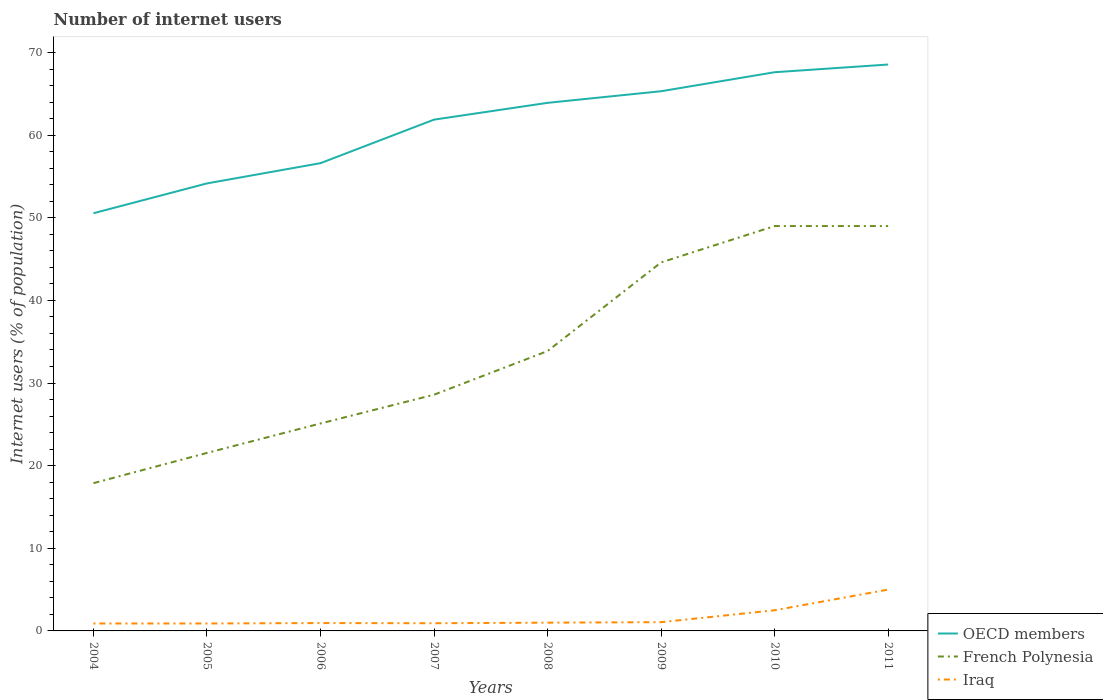Is the number of lines equal to the number of legend labels?
Provide a short and direct response. Yes. Across all years, what is the maximum number of internet users in French Polynesia?
Your answer should be very brief. 17.88. What is the total number of internet users in OECD members in the graph?
Offer a very short reply. -7.72. What is the difference between the highest and the second highest number of internet users in French Polynesia?
Keep it short and to the point. 31.12. What is the difference between the highest and the lowest number of internet users in French Polynesia?
Offer a very short reply. 4. How many years are there in the graph?
Offer a very short reply. 8. What is the difference between two consecutive major ticks on the Y-axis?
Offer a very short reply. 10. Does the graph contain any zero values?
Your answer should be very brief. No. Where does the legend appear in the graph?
Provide a short and direct response. Bottom right. How many legend labels are there?
Your answer should be compact. 3. What is the title of the graph?
Ensure brevity in your answer.  Number of internet users. Does "Suriname" appear as one of the legend labels in the graph?
Provide a short and direct response. No. What is the label or title of the X-axis?
Provide a short and direct response. Years. What is the label or title of the Y-axis?
Give a very brief answer. Internet users (% of population). What is the Internet users (% of population) of OECD members in 2004?
Your answer should be very brief. 50.55. What is the Internet users (% of population) of French Polynesia in 2004?
Provide a succinct answer. 17.88. What is the Internet users (% of population) in OECD members in 2005?
Your answer should be very brief. 54.16. What is the Internet users (% of population) in French Polynesia in 2005?
Provide a succinct answer. 21.54. What is the Internet users (% of population) in Iraq in 2005?
Your answer should be very brief. 0.9. What is the Internet users (% of population) in OECD members in 2006?
Give a very brief answer. 56.61. What is the Internet users (% of population) in French Polynesia in 2006?
Keep it short and to the point. 25.11. What is the Internet users (% of population) of Iraq in 2006?
Keep it short and to the point. 0.95. What is the Internet users (% of population) in OECD members in 2007?
Provide a short and direct response. 61.88. What is the Internet users (% of population) in French Polynesia in 2007?
Keep it short and to the point. 28.59. What is the Internet users (% of population) of Iraq in 2007?
Provide a short and direct response. 0.93. What is the Internet users (% of population) of OECD members in 2008?
Your answer should be very brief. 63.91. What is the Internet users (% of population) in French Polynesia in 2008?
Your answer should be very brief. 33.87. What is the Internet users (% of population) of Iraq in 2008?
Your answer should be very brief. 1. What is the Internet users (% of population) of OECD members in 2009?
Give a very brief answer. 65.32. What is the Internet users (% of population) in French Polynesia in 2009?
Your answer should be compact. 44.6. What is the Internet users (% of population) of Iraq in 2009?
Offer a terse response. 1.06. What is the Internet users (% of population) of OECD members in 2010?
Your response must be concise. 67.62. What is the Internet users (% of population) in French Polynesia in 2010?
Your answer should be compact. 49. What is the Internet users (% of population) in OECD members in 2011?
Give a very brief answer. 68.55. What is the Internet users (% of population) of French Polynesia in 2011?
Offer a very short reply. 49. What is the Internet users (% of population) in Iraq in 2011?
Keep it short and to the point. 5. Across all years, what is the maximum Internet users (% of population) in OECD members?
Give a very brief answer. 68.55. Across all years, what is the maximum Internet users (% of population) of French Polynesia?
Give a very brief answer. 49. Across all years, what is the maximum Internet users (% of population) of Iraq?
Provide a short and direct response. 5. Across all years, what is the minimum Internet users (% of population) in OECD members?
Your answer should be very brief. 50.55. Across all years, what is the minimum Internet users (% of population) in French Polynesia?
Offer a terse response. 17.88. Across all years, what is the minimum Internet users (% of population) of Iraq?
Offer a very short reply. 0.9. What is the total Internet users (% of population) of OECD members in the graph?
Make the answer very short. 488.61. What is the total Internet users (% of population) of French Polynesia in the graph?
Keep it short and to the point. 269.59. What is the total Internet users (% of population) in Iraq in the graph?
Your answer should be very brief. 13.24. What is the difference between the Internet users (% of population) of OECD members in 2004 and that in 2005?
Ensure brevity in your answer.  -3.61. What is the difference between the Internet users (% of population) of French Polynesia in 2004 and that in 2005?
Your answer should be very brief. -3.66. What is the difference between the Internet users (% of population) in OECD members in 2004 and that in 2006?
Your answer should be very brief. -6.06. What is the difference between the Internet users (% of population) in French Polynesia in 2004 and that in 2006?
Your answer should be very brief. -7.22. What is the difference between the Internet users (% of population) of Iraq in 2004 and that in 2006?
Your answer should be very brief. -0.05. What is the difference between the Internet users (% of population) in OECD members in 2004 and that in 2007?
Your answer should be compact. -11.33. What is the difference between the Internet users (% of population) in French Polynesia in 2004 and that in 2007?
Your response must be concise. -10.71. What is the difference between the Internet users (% of population) in Iraq in 2004 and that in 2007?
Offer a very short reply. -0.03. What is the difference between the Internet users (% of population) of OECD members in 2004 and that in 2008?
Your answer should be compact. -13.36. What is the difference between the Internet users (% of population) in French Polynesia in 2004 and that in 2008?
Offer a terse response. -15.99. What is the difference between the Internet users (% of population) of OECD members in 2004 and that in 2009?
Provide a succinct answer. -14.77. What is the difference between the Internet users (% of population) in French Polynesia in 2004 and that in 2009?
Keep it short and to the point. -26.72. What is the difference between the Internet users (% of population) of Iraq in 2004 and that in 2009?
Your answer should be compact. -0.16. What is the difference between the Internet users (% of population) of OECD members in 2004 and that in 2010?
Keep it short and to the point. -17.07. What is the difference between the Internet users (% of population) in French Polynesia in 2004 and that in 2010?
Give a very brief answer. -31.12. What is the difference between the Internet users (% of population) in OECD members in 2004 and that in 2011?
Ensure brevity in your answer.  -18. What is the difference between the Internet users (% of population) of French Polynesia in 2004 and that in 2011?
Keep it short and to the point. -31.12. What is the difference between the Internet users (% of population) in Iraq in 2004 and that in 2011?
Offer a very short reply. -4.1. What is the difference between the Internet users (% of population) in OECD members in 2005 and that in 2006?
Your answer should be compact. -2.45. What is the difference between the Internet users (% of population) in French Polynesia in 2005 and that in 2006?
Your answer should be very brief. -3.57. What is the difference between the Internet users (% of population) of Iraq in 2005 and that in 2006?
Give a very brief answer. -0.05. What is the difference between the Internet users (% of population) in OECD members in 2005 and that in 2007?
Provide a succinct answer. -7.72. What is the difference between the Internet users (% of population) of French Polynesia in 2005 and that in 2007?
Keep it short and to the point. -7.05. What is the difference between the Internet users (% of population) of Iraq in 2005 and that in 2007?
Provide a short and direct response. -0.03. What is the difference between the Internet users (% of population) of OECD members in 2005 and that in 2008?
Make the answer very short. -9.75. What is the difference between the Internet users (% of population) of French Polynesia in 2005 and that in 2008?
Provide a succinct answer. -12.33. What is the difference between the Internet users (% of population) of Iraq in 2005 and that in 2008?
Offer a very short reply. -0.1. What is the difference between the Internet users (% of population) of OECD members in 2005 and that in 2009?
Offer a very short reply. -11.16. What is the difference between the Internet users (% of population) in French Polynesia in 2005 and that in 2009?
Provide a succinct answer. -23.06. What is the difference between the Internet users (% of population) in Iraq in 2005 and that in 2009?
Ensure brevity in your answer.  -0.16. What is the difference between the Internet users (% of population) of OECD members in 2005 and that in 2010?
Your response must be concise. -13.46. What is the difference between the Internet users (% of population) of French Polynesia in 2005 and that in 2010?
Provide a succinct answer. -27.46. What is the difference between the Internet users (% of population) in OECD members in 2005 and that in 2011?
Give a very brief answer. -14.39. What is the difference between the Internet users (% of population) of French Polynesia in 2005 and that in 2011?
Provide a succinct answer. -27.46. What is the difference between the Internet users (% of population) of Iraq in 2005 and that in 2011?
Ensure brevity in your answer.  -4.1. What is the difference between the Internet users (% of population) of OECD members in 2006 and that in 2007?
Ensure brevity in your answer.  -5.27. What is the difference between the Internet users (% of population) of French Polynesia in 2006 and that in 2007?
Provide a short and direct response. -3.48. What is the difference between the Internet users (% of population) of Iraq in 2006 and that in 2007?
Your response must be concise. 0.02. What is the difference between the Internet users (% of population) of OECD members in 2006 and that in 2008?
Your response must be concise. -7.3. What is the difference between the Internet users (% of population) of French Polynesia in 2006 and that in 2008?
Provide a succinct answer. -8.76. What is the difference between the Internet users (% of population) in Iraq in 2006 and that in 2008?
Give a very brief answer. -0.05. What is the difference between the Internet users (% of population) of OECD members in 2006 and that in 2009?
Your answer should be compact. -8.71. What is the difference between the Internet users (% of population) of French Polynesia in 2006 and that in 2009?
Offer a very short reply. -19.49. What is the difference between the Internet users (% of population) in Iraq in 2006 and that in 2009?
Offer a terse response. -0.11. What is the difference between the Internet users (% of population) of OECD members in 2006 and that in 2010?
Provide a succinct answer. -11.01. What is the difference between the Internet users (% of population) of French Polynesia in 2006 and that in 2010?
Provide a succinct answer. -23.89. What is the difference between the Internet users (% of population) in Iraq in 2006 and that in 2010?
Your answer should be very brief. -1.55. What is the difference between the Internet users (% of population) in OECD members in 2006 and that in 2011?
Offer a terse response. -11.94. What is the difference between the Internet users (% of population) in French Polynesia in 2006 and that in 2011?
Give a very brief answer. -23.89. What is the difference between the Internet users (% of population) of Iraq in 2006 and that in 2011?
Ensure brevity in your answer.  -4.05. What is the difference between the Internet users (% of population) in OECD members in 2007 and that in 2008?
Your answer should be compact. -2.03. What is the difference between the Internet users (% of population) of French Polynesia in 2007 and that in 2008?
Ensure brevity in your answer.  -5.28. What is the difference between the Internet users (% of population) in Iraq in 2007 and that in 2008?
Keep it short and to the point. -0.07. What is the difference between the Internet users (% of population) in OECD members in 2007 and that in 2009?
Offer a terse response. -3.44. What is the difference between the Internet users (% of population) in French Polynesia in 2007 and that in 2009?
Make the answer very short. -16.01. What is the difference between the Internet users (% of population) in Iraq in 2007 and that in 2009?
Provide a short and direct response. -0.13. What is the difference between the Internet users (% of population) in OECD members in 2007 and that in 2010?
Give a very brief answer. -5.74. What is the difference between the Internet users (% of population) of French Polynesia in 2007 and that in 2010?
Keep it short and to the point. -20.41. What is the difference between the Internet users (% of population) in Iraq in 2007 and that in 2010?
Your answer should be very brief. -1.57. What is the difference between the Internet users (% of population) of OECD members in 2007 and that in 2011?
Offer a very short reply. -6.67. What is the difference between the Internet users (% of population) in French Polynesia in 2007 and that in 2011?
Ensure brevity in your answer.  -20.41. What is the difference between the Internet users (% of population) of Iraq in 2007 and that in 2011?
Give a very brief answer. -4.07. What is the difference between the Internet users (% of population) of OECD members in 2008 and that in 2009?
Your response must be concise. -1.41. What is the difference between the Internet users (% of population) in French Polynesia in 2008 and that in 2009?
Provide a succinct answer. -10.73. What is the difference between the Internet users (% of population) in Iraq in 2008 and that in 2009?
Your response must be concise. -0.06. What is the difference between the Internet users (% of population) in OECD members in 2008 and that in 2010?
Ensure brevity in your answer.  -3.71. What is the difference between the Internet users (% of population) in French Polynesia in 2008 and that in 2010?
Your answer should be compact. -15.13. What is the difference between the Internet users (% of population) of OECD members in 2008 and that in 2011?
Provide a succinct answer. -4.64. What is the difference between the Internet users (% of population) in French Polynesia in 2008 and that in 2011?
Ensure brevity in your answer.  -15.13. What is the difference between the Internet users (% of population) of Iraq in 2008 and that in 2011?
Make the answer very short. -4. What is the difference between the Internet users (% of population) in OECD members in 2009 and that in 2010?
Give a very brief answer. -2.3. What is the difference between the Internet users (% of population) of Iraq in 2009 and that in 2010?
Keep it short and to the point. -1.44. What is the difference between the Internet users (% of population) in OECD members in 2009 and that in 2011?
Give a very brief answer. -3.23. What is the difference between the Internet users (% of population) in Iraq in 2009 and that in 2011?
Offer a terse response. -3.94. What is the difference between the Internet users (% of population) of OECD members in 2010 and that in 2011?
Keep it short and to the point. -0.93. What is the difference between the Internet users (% of population) in French Polynesia in 2010 and that in 2011?
Ensure brevity in your answer.  0. What is the difference between the Internet users (% of population) in Iraq in 2010 and that in 2011?
Your answer should be compact. -2.5. What is the difference between the Internet users (% of population) of OECD members in 2004 and the Internet users (% of population) of French Polynesia in 2005?
Offer a terse response. 29.01. What is the difference between the Internet users (% of population) of OECD members in 2004 and the Internet users (% of population) of Iraq in 2005?
Provide a succinct answer. 49.65. What is the difference between the Internet users (% of population) of French Polynesia in 2004 and the Internet users (% of population) of Iraq in 2005?
Your answer should be very brief. 16.98. What is the difference between the Internet users (% of population) in OECD members in 2004 and the Internet users (% of population) in French Polynesia in 2006?
Make the answer very short. 25.44. What is the difference between the Internet users (% of population) in OECD members in 2004 and the Internet users (% of population) in Iraq in 2006?
Provide a short and direct response. 49.6. What is the difference between the Internet users (% of population) of French Polynesia in 2004 and the Internet users (% of population) of Iraq in 2006?
Your answer should be compact. 16.93. What is the difference between the Internet users (% of population) of OECD members in 2004 and the Internet users (% of population) of French Polynesia in 2007?
Provide a succinct answer. 21.96. What is the difference between the Internet users (% of population) in OECD members in 2004 and the Internet users (% of population) in Iraq in 2007?
Make the answer very short. 49.62. What is the difference between the Internet users (% of population) in French Polynesia in 2004 and the Internet users (% of population) in Iraq in 2007?
Make the answer very short. 16.95. What is the difference between the Internet users (% of population) of OECD members in 2004 and the Internet users (% of population) of French Polynesia in 2008?
Ensure brevity in your answer.  16.68. What is the difference between the Internet users (% of population) of OECD members in 2004 and the Internet users (% of population) of Iraq in 2008?
Ensure brevity in your answer.  49.55. What is the difference between the Internet users (% of population) of French Polynesia in 2004 and the Internet users (% of population) of Iraq in 2008?
Provide a short and direct response. 16.88. What is the difference between the Internet users (% of population) of OECD members in 2004 and the Internet users (% of population) of French Polynesia in 2009?
Your answer should be compact. 5.95. What is the difference between the Internet users (% of population) of OECD members in 2004 and the Internet users (% of population) of Iraq in 2009?
Give a very brief answer. 49.49. What is the difference between the Internet users (% of population) of French Polynesia in 2004 and the Internet users (% of population) of Iraq in 2009?
Give a very brief answer. 16.82. What is the difference between the Internet users (% of population) of OECD members in 2004 and the Internet users (% of population) of French Polynesia in 2010?
Give a very brief answer. 1.55. What is the difference between the Internet users (% of population) of OECD members in 2004 and the Internet users (% of population) of Iraq in 2010?
Give a very brief answer. 48.05. What is the difference between the Internet users (% of population) of French Polynesia in 2004 and the Internet users (% of population) of Iraq in 2010?
Make the answer very short. 15.38. What is the difference between the Internet users (% of population) of OECD members in 2004 and the Internet users (% of population) of French Polynesia in 2011?
Offer a terse response. 1.55. What is the difference between the Internet users (% of population) in OECD members in 2004 and the Internet users (% of population) in Iraq in 2011?
Your answer should be very brief. 45.55. What is the difference between the Internet users (% of population) of French Polynesia in 2004 and the Internet users (% of population) of Iraq in 2011?
Provide a short and direct response. 12.88. What is the difference between the Internet users (% of population) in OECD members in 2005 and the Internet users (% of population) in French Polynesia in 2006?
Ensure brevity in your answer.  29.05. What is the difference between the Internet users (% of population) in OECD members in 2005 and the Internet users (% of population) in Iraq in 2006?
Offer a very short reply. 53.21. What is the difference between the Internet users (% of population) in French Polynesia in 2005 and the Internet users (% of population) in Iraq in 2006?
Give a very brief answer. 20.59. What is the difference between the Internet users (% of population) in OECD members in 2005 and the Internet users (% of population) in French Polynesia in 2007?
Give a very brief answer. 25.57. What is the difference between the Internet users (% of population) of OECD members in 2005 and the Internet users (% of population) of Iraq in 2007?
Your answer should be very brief. 53.23. What is the difference between the Internet users (% of population) in French Polynesia in 2005 and the Internet users (% of population) in Iraq in 2007?
Offer a terse response. 20.61. What is the difference between the Internet users (% of population) of OECD members in 2005 and the Internet users (% of population) of French Polynesia in 2008?
Your answer should be very brief. 20.29. What is the difference between the Internet users (% of population) of OECD members in 2005 and the Internet users (% of population) of Iraq in 2008?
Ensure brevity in your answer.  53.16. What is the difference between the Internet users (% of population) in French Polynesia in 2005 and the Internet users (% of population) in Iraq in 2008?
Give a very brief answer. 20.54. What is the difference between the Internet users (% of population) of OECD members in 2005 and the Internet users (% of population) of French Polynesia in 2009?
Provide a succinct answer. 9.56. What is the difference between the Internet users (% of population) in OECD members in 2005 and the Internet users (% of population) in Iraq in 2009?
Your answer should be very brief. 53.1. What is the difference between the Internet users (% of population) in French Polynesia in 2005 and the Internet users (% of population) in Iraq in 2009?
Your answer should be very brief. 20.48. What is the difference between the Internet users (% of population) of OECD members in 2005 and the Internet users (% of population) of French Polynesia in 2010?
Offer a very short reply. 5.16. What is the difference between the Internet users (% of population) of OECD members in 2005 and the Internet users (% of population) of Iraq in 2010?
Ensure brevity in your answer.  51.66. What is the difference between the Internet users (% of population) of French Polynesia in 2005 and the Internet users (% of population) of Iraq in 2010?
Ensure brevity in your answer.  19.04. What is the difference between the Internet users (% of population) of OECD members in 2005 and the Internet users (% of population) of French Polynesia in 2011?
Offer a terse response. 5.16. What is the difference between the Internet users (% of population) of OECD members in 2005 and the Internet users (% of population) of Iraq in 2011?
Make the answer very short. 49.16. What is the difference between the Internet users (% of population) of French Polynesia in 2005 and the Internet users (% of population) of Iraq in 2011?
Ensure brevity in your answer.  16.54. What is the difference between the Internet users (% of population) of OECD members in 2006 and the Internet users (% of population) of French Polynesia in 2007?
Your response must be concise. 28.02. What is the difference between the Internet users (% of population) in OECD members in 2006 and the Internet users (% of population) in Iraq in 2007?
Your response must be concise. 55.68. What is the difference between the Internet users (% of population) in French Polynesia in 2006 and the Internet users (% of population) in Iraq in 2007?
Your answer should be very brief. 24.18. What is the difference between the Internet users (% of population) of OECD members in 2006 and the Internet users (% of population) of French Polynesia in 2008?
Provide a short and direct response. 22.74. What is the difference between the Internet users (% of population) in OECD members in 2006 and the Internet users (% of population) in Iraq in 2008?
Offer a very short reply. 55.61. What is the difference between the Internet users (% of population) in French Polynesia in 2006 and the Internet users (% of population) in Iraq in 2008?
Provide a succinct answer. 24.11. What is the difference between the Internet users (% of population) of OECD members in 2006 and the Internet users (% of population) of French Polynesia in 2009?
Your response must be concise. 12.01. What is the difference between the Internet users (% of population) of OECD members in 2006 and the Internet users (% of population) of Iraq in 2009?
Ensure brevity in your answer.  55.55. What is the difference between the Internet users (% of population) of French Polynesia in 2006 and the Internet users (% of population) of Iraq in 2009?
Keep it short and to the point. 24.05. What is the difference between the Internet users (% of population) of OECD members in 2006 and the Internet users (% of population) of French Polynesia in 2010?
Offer a very short reply. 7.61. What is the difference between the Internet users (% of population) of OECD members in 2006 and the Internet users (% of population) of Iraq in 2010?
Give a very brief answer. 54.11. What is the difference between the Internet users (% of population) of French Polynesia in 2006 and the Internet users (% of population) of Iraq in 2010?
Make the answer very short. 22.61. What is the difference between the Internet users (% of population) in OECD members in 2006 and the Internet users (% of population) in French Polynesia in 2011?
Offer a terse response. 7.61. What is the difference between the Internet users (% of population) in OECD members in 2006 and the Internet users (% of population) in Iraq in 2011?
Make the answer very short. 51.61. What is the difference between the Internet users (% of population) of French Polynesia in 2006 and the Internet users (% of population) of Iraq in 2011?
Provide a short and direct response. 20.11. What is the difference between the Internet users (% of population) of OECD members in 2007 and the Internet users (% of population) of French Polynesia in 2008?
Offer a very short reply. 28.01. What is the difference between the Internet users (% of population) of OECD members in 2007 and the Internet users (% of population) of Iraq in 2008?
Offer a terse response. 60.88. What is the difference between the Internet users (% of population) of French Polynesia in 2007 and the Internet users (% of population) of Iraq in 2008?
Ensure brevity in your answer.  27.59. What is the difference between the Internet users (% of population) of OECD members in 2007 and the Internet users (% of population) of French Polynesia in 2009?
Ensure brevity in your answer.  17.28. What is the difference between the Internet users (% of population) in OECD members in 2007 and the Internet users (% of population) in Iraq in 2009?
Provide a short and direct response. 60.82. What is the difference between the Internet users (% of population) in French Polynesia in 2007 and the Internet users (% of population) in Iraq in 2009?
Your response must be concise. 27.53. What is the difference between the Internet users (% of population) of OECD members in 2007 and the Internet users (% of population) of French Polynesia in 2010?
Your response must be concise. 12.88. What is the difference between the Internet users (% of population) in OECD members in 2007 and the Internet users (% of population) in Iraq in 2010?
Offer a terse response. 59.38. What is the difference between the Internet users (% of population) of French Polynesia in 2007 and the Internet users (% of population) of Iraq in 2010?
Make the answer very short. 26.09. What is the difference between the Internet users (% of population) in OECD members in 2007 and the Internet users (% of population) in French Polynesia in 2011?
Your answer should be very brief. 12.88. What is the difference between the Internet users (% of population) of OECD members in 2007 and the Internet users (% of population) of Iraq in 2011?
Ensure brevity in your answer.  56.88. What is the difference between the Internet users (% of population) in French Polynesia in 2007 and the Internet users (% of population) in Iraq in 2011?
Your answer should be compact. 23.59. What is the difference between the Internet users (% of population) in OECD members in 2008 and the Internet users (% of population) in French Polynesia in 2009?
Make the answer very short. 19.31. What is the difference between the Internet users (% of population) in OECD members in 2008 and the Internet users (% of population) in Iraq in 2009?
Your response must be concise. 62.85. What is the difference between the Internet users (% of population) of French Polynesia in 2008 and the Internet users (% of population) of Iraq in 2009?
Provide a short and direct response. 32.81. What is the difference between the Internet users (% of population) in OECD members in 2008 and the Internet users (% of population) in French Polynesia in 2010?
Make the answer very short. 14.91. What is the difference between the Internet users (% of population) in OECD members in 2008 and the Internet users (% of population) in Iraq in 2010?
Your answer should be very brief. 61.41. What is the difference between the Internet users (% of population) in French Polynesia in 2008 and the Internet users (% of population) in Iraq in 2010?
Offer a terse response. 31.37. What is the difference between the Internet users (% of population) of OECD members in 2008 and the Internet users (% of population) of French Polynesia in 2011?
Offer a terse response. 14.91. What is the difference between the Internet users (% of population) in OECD members in 2008 and the Internet users (% of population) in Iraq in 2011?
Your answer should be very brief. 58.91. What is the difference between the Internet users (% of population) of French Polynesia in 2008 and the Internet users (% of population) of Iraq in 2011?
Offer a terse response. 28.87. What is the difference between the Internet users (% of population) in OECD members in 2009 and the Internet users (% of population) in French Polynesia in 2010?
Keep it short and to the point. 16.32. What is the difference between the Internet users (% of population) of OECD members in 2009 and the Internet users (% of population) of Iraq in 2010?
Provide a short and direct response. 62.82. What is the difference between the Internet users (% of population) in French Polynesia in 2009 and the Internet users (% of population) in Iraq in 2010?
Your response must be concise. 42.1. What is the difference between the Internet users (% of population) in OECD members in 2009 and the Internet users (% of population) in French Polynesia in 2011?
Provide a succinct answer. 16.32. What is the difference between the Internet users (% of population) in OECD members in 2009 and the Internet users (% of population) in Iraq in 2011?
Your response must be concise. 60.32. What is the difference between the Internet users (% of population) in French Polynesia in 2009 and the Internet users (% of population) in Iraq in 2011?
Your answer should be compact. 39.6. What is the difference between the Internet users (% of population) of OECD members in 2010 and the Internet users (% of population) of French Polynesia in 2011?
Your answer should be very brief. 18.62. What is the difference between the Internet users (% of population) in OECD members in 2010 and the Internet users (% of population) in Iraq in 2011?
Offer a very short reply. 62.62. What is the average Internet users (% of population) of OECD members per year?
Your answer should be compact. 61.08. What is the average Internet users (% of population) of French Polynesia per year?
Your answer should be very brief. 33.7. What is the average Internet users (% of population) of Iraq per year?
Your answer should be compact. 1.66. In the year 2004, what is the difference between the Internet users (% of population) of OECD members and Internet users (% of population) of French Polynesia?
Your response must be concise. 32.67. In the year 2004, what is the difference between the Internet users (% of population) of OECD members and Internet users (% of population) of Iraq?
Provide a succinct answer. 49.65. In the year 2004, what is the difference between the Internet users (% of population) in French Polynesia and Internet users (% of population) in Iraq?
Give a very brief answer. 16.98. In the year 2005, what is the difference between the Internet users (% of population) in OECD members and Internet users (% of population) in French Polynesia?
Provide a short and direct response. 32.62. In the year 2005, what is the difference between the Internet users (% of population) in OECD members and Internet users (% of population) in Iraq?
Ensure brevity in your answer.  53.26. In the year 2005, what is the difference between the Internet users (% of population) of French Polynesia and Internet users (% of population) of Iraq?
Ensure brevity in your answer.  20.64. In the year 2006, what is the difference between the Internet users (% of population) of OECD members and Internet users (% of population) of French Polynesia?
Your response must be concise. 31.5. In the year 2006, what is the difference between the Internet users (% of population) of OECD members and Internet users (% of population) of Iraq?
Offer a terse response. 55.66. In the year 2006, what is the difference between the Internet users (% of population) in French Polynesia and Internet users (% of population) in Iraq?
Keep it short and to the point. 24.16. In the year 2007, what is the difference between the Internet users (% of population) of OECD members and Internet users (% of population) of French Polynesia?
Offer a terse response. 33.29. In the year 2007, what is the difference between the Internet users (% of population) in OECD members and Internet users (% of population) in Iraq?
Your response must be concise. 60.95. In the year 2007, what is the difference between the Internet users (% of population) in French Polynesia and Internet users (% of population) in Iraq?
Make the answer very short. 27.66. In the year 2008, what is the difference between the Internet users (% of population) in OECD members and Internet users (% of population) in French Polynesia?
Ensure brevity in your answer.  30.04. In the year 2008, what is the difference between the Internet users (% of population) of OECD members and Internet users (% of population) of Iraq?
Provide a short and direct response. 62.91. In the year 2008, what is the difference between the Internet users (% of population) of French Polynesia and Internet users (% of population) of Iraq?
Your response must be concise. 32.87. In the year 2009, what is the difference between the Internet users (% of population) of OECD members and Internet users (% of population) of French Polynesia?
Make the answer very short. 20.72. In the year 2009, what is the difference between the Internet users (% of population) in OECD members and Internet users (% of population) in Iraq?
Your answer should be compact. 64.26. In the year 2009, what is the difference between the Internet users (% of population) of French Polynesia and Internet users (% of population) of Iraq?
Give a very brief answer. 43.54. In the year 2010, what is the difference between the Internet users (% of population) in OECD members and Internet users (% of population) in French Polynesia?
Offer a terse response. 18.62. In the year 2010, what is the difference between the Internet users (% of population) of OECD members and Internet users (% of population) of Iraq?
Offer a very short reply. 65.12. In the year 2010, what is the difference between the Internet users (% of population) in French Polynesia and Internet users (% of population) in Iraq?
Offer a very short reply. 46.5. In the year 2011, what is the difference between the Internet users (% of population) of OECD members and Internet users (% of population) of French Polynesia?
Your answer should be very brief. 19.55. In the year 2011, what is the difference between the Internet users (% of population) of OECD members and Internet users (% of population) of Iraq?
Offer a terse response. 63.55. What is the ratio of the Internet users (% of population) of OECD members in 2004 to that in 2005?
Make the answer very short. 0.93. What is the ratio of the Internet users (% of population) in French Polynesia in 2004 to that in 2005?
Provide a succinct answer. 0.83. What is the ratio of the Internet users (% of population) of Iraq in 2004 to that in 2005?
Give a very brief answer. 1. What is the ratio of the Internet users (% of population) of OECD members in 2004 to that in 2006?
Your answer should be compact. 0.89. What is the ratio of the Internet users (% of population) in French Polynesia in 2004 to that in 2006?
Your response must be concise. 0.71. What is the ratio of the Internet users (% of population) of Iraq in 2004 to that in 2006?
Make the answer very short. 0.94. What is the ratio of the Internet users (% of population) in OECD members in 2004 to that in 2007?
Your answer should be very brief. 0.82. What is the ratio of the Internet users (% of population) in French Polynesia in 2004 to that in 2007?
Give a very brief answer. 0.63. What is the ratio of the Internet users (% of population) of OECD members in 2004 to that in 2008?
Make the answer very short. 0.79. What is the ratio of the Internet users (% of population) in French Polynesia in 2004 to that in 2008?
Provide a succinct answer. 0.53. What is the ratio of the Internet users (% of population) of OECD members in 2004 to that in 2009?
Offer a very short reply. 0.77. What is the ratio of the Internet users (% of population) in French Polynesia in 2004 to that in 2009?
Your response must be concise. 0.4. What is the ratio of the Internet users (% of population) in Iraq in 2004 to that in 2009?
Provide a succinct answer. 0.85. What is the ratio of the Internet users (% of population) in OECD members in 2004 to that in 2010?
Keep it short and to the point. 0.75. What is the ratio of the Internet users (% of population) in French Polynesia in 2004 to that in 2010?
Offer a terse response. 0.36. What is the ratio of the Internet users (% of population) in Iraq in 2004 to that in 2010?
Your answer should be very brief. 0.36. What is the ratio of the Internet users (% of population) of OECD members in 2004 to that in 2011?
Your answer should be compact. 0.74. What is the ratio of the Internet users (% of population) of French Polynesia in 2004 to that in 2011?
Your answer should be very brief. 0.36. What is the ratio of the Internet users (% of population) in Iraq in 2004 to that in 2011?
Your answer should be very brief. 0.18. What is the ratio of the Internet users (% of population) in OECD members in 2005 to that in 2006?
Your response must be concise. 0.96. What is the ratio of the Internet users (% of population) in French Polynesia in 2005 to that in 2006?
Give a very brief answer. 0.86. What is the ratio of the Internet users (% of population) in Iraq in 2005 to that in 2006?
Your answer should be very brief. 0.94. What is the ratio of the Internet users (% of population) in OECD members in 2005 to that in 2007?
Give a very brief answer. 0.88. What is the ratio of the Internet users (% of population) in French Polynesia in 2005 to that in 2007?
Provide a succinct answer. 0.75. What is the ratio of the Internet users (% of population) in Iraq in 2005 to that in 2007?
Give a very brief answer. 0.97. What is the ratio of the Internet users (% of population) of OECD members in 2005 to that in 2008?
Make the answer very short. 0.85. What is the ratio of the Internet users (% of population) in French Polynesia in 2005 to that in 2008?
Your answer should be compact. 0.64. What is the ratio of the Internet users (% of population) in Iraq in 2005 to that in 2008?
Offer a terse response. 0.9. What is the ratio of the Internet users (% of population) of OECD members in 2005 to that in 2009?
Keep it short and to the point. 0.83. What is the ratio of the Internet users (% of population) of French Polynesia in 2005 to that in 2009?
Your response must be concise. 0.48. What is the ratio of the Internet users (% of population) in Iraq in 2005 to that in 2009?
Your answer should be very brief. 0.85. What is the ratio of the Internet users (% of population) in OECD members in 2005 to that in 2010?
Make the answer very short. 0.8. What is the ratio of the Internet users (% of population) in French Polynesia in 2005 to that in 2010?
Your response must be concise. 0.44. What is the ratio of the Internet users (% of population) of Iraq in 2005 to that in 2010?
Ensure brevity in your answer.  0.36. What is the ratio of the Internet users (% of population) of OECD members in 2005 to that in 2011?
Your response must be concise. 0.79. What is the ratio of the Internet users (% of population) of French Polynesia in 2005 to that in 2011?
Offer a terse response. 0.44. What is the ratio of the Internet users (% of population) in Iraq in 2005 to that in 2011?
Provide a short and direct response. 0.18. What is the ratio of the Internet users (% of population) of OECD members in 2006 to that in 2007?
Keep it short and to the point. 0.91. What is the ratio of the Internet users (% of population) of French Polynesia in 2006 to that in 2007?
Provide a succinct answer. 0.88. What is the ratio of the Internet users (% of population) in OECD members in 2006 to that in 2008?
Ensure brevity in your answer.  0.89. What is the ratio of the Internet users (% of population) of French Polynesia in 2006 to that in 2008?
Ensure brevity in your answer.  0.74. What is the ratio of the Internet users (% of population) in Iraq in 2006 to that in 2008?
Keep it short and to the point. 0.95. What is the ratio of the Internet users (% of population) in OECD members in 2006 to that in 2009?
Make the answer very short. 0.87. What is the ratio of the Internet users (% of population) in French Polynesia in 2006 to that in 2009?
Keep it short and to the point. 0.56. What is the ratio of the Internet users (% of population) of Iraq in 2006 to that in 2009?
Offer a terse response. 0.9. What is the ratio of the Internet users (% of population) in OECD members in 2006 to that in 2010?
Ensure brevity in your answer.  0.84. What is the ratio of the Internet users (% of population) of French Polynesia in 2006 to that in 2010?
Offer a very short reply. 0.51. What is the ratio of the Internet users (% of population) of Iraq in 2006 to that in 2010?
Your response must be concise. 0.38. What is the ratio of the Internet users (% of population) of OECD members in 2006 to that in 2011?
Offer a terse response. 0.83. What is the ratio of the Internet users (% of population) of French Polynesia in 2006 to that in 2011?
Provide a short and direct response. 0.51. What is the ratio of the Internet users (% of population) of Iraq in 2006 to that in 2011?
Your response must be concise. 0.19. What is the ratio of the Internet users (% of population) of OECD members in 2007 to that in 2008?
Provide a short and direct response. 0.97. What is the ratio of the Internet users (% of population) in French Polynesia in 2007 to that in 2008?
Keep it short and to the point. 0.84. What is the ratio of the Internet users (% of population) of OECD members in 2007 to that in 2009?
Provide a short and direct response. 0.95. What is the ratio of the Internet users (% of population) of French Polynesia in 2007 to that in 2009?
Provide a succinct answer. 0.64. What is the ratio of the Internet users (% of population) of Iraq in 2007 to that in 2009?
Your answer should be very brief. 0.88. What is the ratio of the Internet users (% of population) of OECD members in 2007 to that in 2010?
Offer a terse response. 0.92. What is the ratio of the Internet users (% of population) in French Polynesia in 2007 to that in 2010?
Provide a short and direct response. 0.58. What is the ratio of the Internet users (% of population) in Iraq in 2007 to that in 2010?
Make the answer very short. 0.37. What is the ratio of the Internet users (% of population) of OECD members in 2007 to that in 2011?
Give a very brief answer. 0.9. What is the ratio of the Internet users (% of population) of French Polynesia in 2007 to that in 2011?
Provide a succinct answer. 0.58. What is the ratio of the Internet users (% of population) in Iraq in 2007 to that in 2011?
Keep it short and to the point. 0.19. What is the ratio of the Internet users (% of population) in OECD members in 2008 to that in 2009?
Offer a terse response. 0.98. What is the ratio of the Internet users (% of population) in French Polynesia in 2008 to that in 2009?
Make the answer very short. 0.76. What is the ratio of the Internet users (% of population) in Iraq in 2008 to that in 2009?
Your answer should be compact. 0.94. What is the ratio of the Internet users (% of population) in OECD members in 2008 to that in 2010?
Keep it short and to the point. 0.95. What is the ratio of the Internet users (% of population) of French Polynesia in 2008 to that in 2010?
Offer a terse response. 0.69. What is the ratio of the Internet users (% of population) of OECD members in 2008 to that in 2011?
Your answer should be compact. 0.93. What is the ratio of the Internet users (% of population) in French Polynesia in 2008 to that in 2011?
Keep it short and to the point. 0.69. What is the ratio of the Internet users (% of population) in French Polynesia in 2009 to that in 2010?
Your answer should be very brief. 0.91. What is the ratio of the Internet users (% of population) of Iraq in 2009 to that in 2010?
Provide a short and direct response. 0.42. What is the ratio of the Internet users (% of population) in OECD members in 2009 to that in 2011?
Make the answer very short. 0.95. What is the ratio of the Internet users (% of population) in French Polynesia in 2009 to that in 2011?
Offer a terse response. 0.91. What is the ratio of the Internet users (% of population) in Iraq in 2009 to that in 2011?
Make the answer very short. 0.21. What is the ratio of the Internet users (% of population) of OECD members in 2010 to that in 2011?
Your answer should be very brief. 0.99. What is the difference between the highest and the second highest Internet users (% of population) of OECD members?
Your answer should be very brief. 0.93. What is the difference between the highest and the second highest Internet users (% of population) in Iraq?
Make the answer very short. 2.5. What is the difference between the highest and the lowest Internet users (% of population) of OECD members?
Provide a succinct answer. 18. What is the difference between the highest and the lowest Internet users (% of population) of French Polynesia?
Keep it short and to the point. 31.12. 